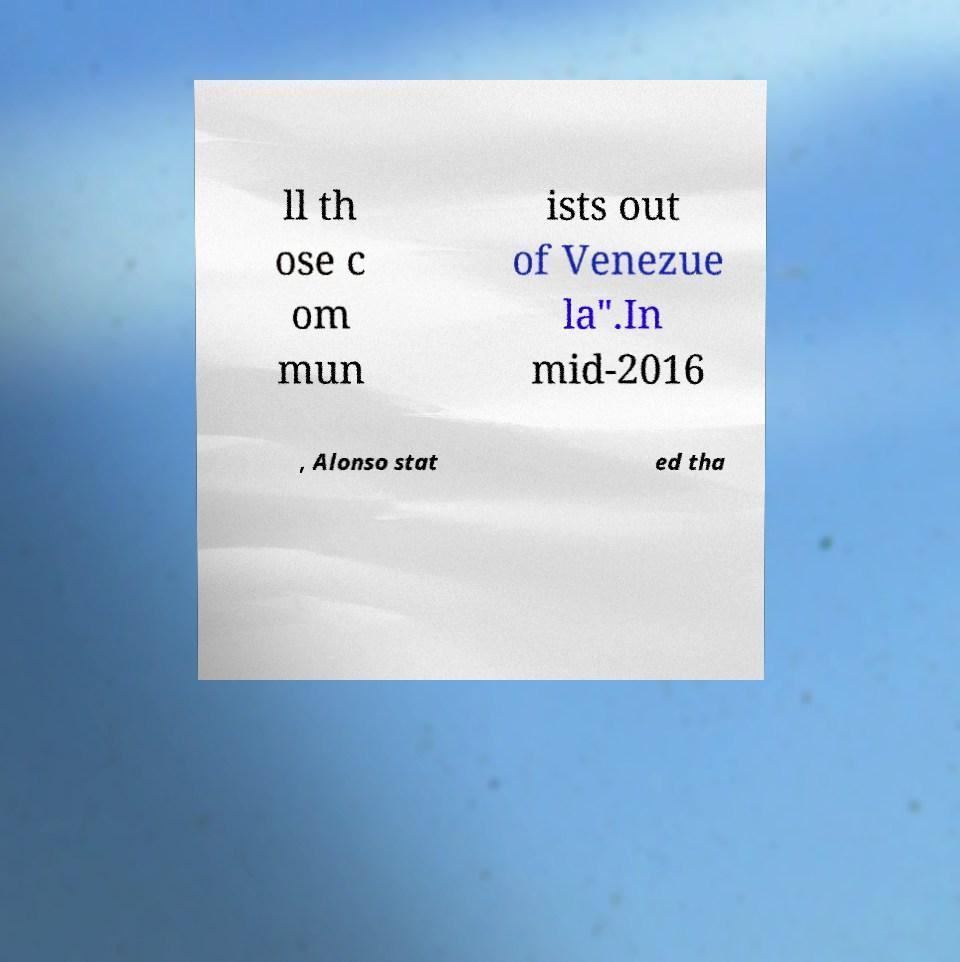There's text embedded in this image that I need extracted. Can you transcribe it verbatim? ll th ose c om mun ists out of Venezue la".In mid-2016 , Alonso stat ed tha 